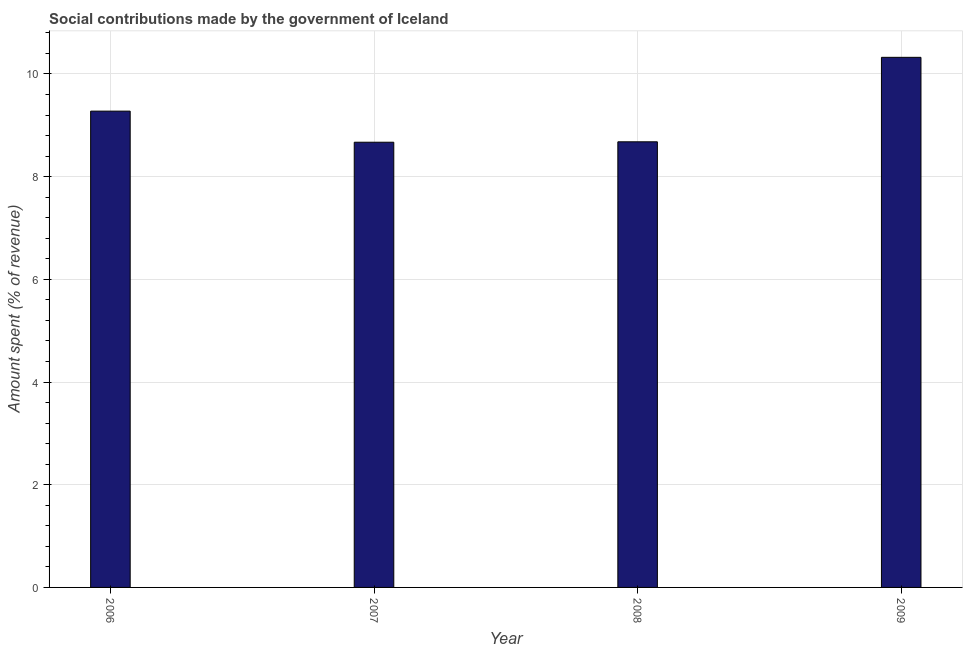Does the graph contain grids?
Offer a very short reply. Yes. What is the title of the graph?
Make the answer very short. Social contributions made by the government of Iceland. What is the label or title of the Y-axis?
Offer a terse response. Amount spent (% of revenue). What is the amount spent in making social contributions in 2009?
Provide a succinct answer. 10.32. Across all years, what is the maximum amount spent in making social contributions?
Provide a succinct answer. 10.32. Across all years, what is the minimum amount spent in making social contributions?
Give a very brief answer. 8.67. In which year was the amount spent in making social contributions maximum?
Provide a short and direct response. 2009. What is the sum of the amount spent in making social contributions?
Provide a short and direct response. 36.95. What is the difference between the amount spent in making social contributions in 2008 and 2009?
Give a very brief answer. -1.65. What is the average amount spent in making social contributions per year?
Your response must be concise. 9.24. What is the median amount spent in making social contributions?
Ensure brevity in your answer.  8.98. In how many years, is the amount spent in making social contributions greater than 1.2 %?
Give a very brief answer. 4. Do a majority of the years between 2009 and 2007 (inclusive) have amount spent in making social contributions greater than 2.4 %?
Your answer should be very brief. Yes. Is the amount spent in making social contributions in 2008 less than that in 2009?
Provide a short and direct response. Yes. What is the difference between the highest and the second highest amount spent in making social contributions?
Your answer should be very brief. 1.05. What is the difference between the highest and the lowest amount spent in making social contributions?
Give a very brief answer. 1.65. In how many years, is the amount spent in making social contributions greater than the average amount spent in making social contributions taken over all years?
Make the answer very short. 2. How many bars are there?
Make the answer very short. 4. Are all the bars in the graph horizontal?
Your answer should be compact. No. What is the Amount spent (% of revenue) of 2006?
Give a very brief answer. 9.28. What is the Amount spent (% of revenue) of 2007?
Keep it short and to the point. 8.67. What is the Amount spent (% of revenue) of 2008?
Ensure brevity in your answer.  8.68. What is the Amount spent (% of revenue) in 2009?
Give a very brief answer. 10.32. What is the difference between the Amount spent (% of revenue) in 2006 and 2007?
Your answer should be very brief. 0.61. What is the difference between the Amount spent (% of revenue) in 2006 and 2008?
Offer a terse response. 0.6. What is the difference between the Amount spent (% of revenue) in 2006 and 2009?
Provide a succinct answer. -1.05. What is the difference between the Amount spent (% of revenue) in 2007 and 2008?
Your response must be concise. -0.01. What is the difference between the Amount spent (% of revenue) in 2007 and 2009?
Your response must be concise. -1.65. What is the difference between the Amount spent (% of revenue) in 2008 and 2009?
Make the answer very short. -1.65. What is the ratio of the Amount spent (% of revenue) in 2006 to that in 2007?
Your answer should be very brief. 1.07. What is the ratio of the Amount spent (% of revenue) in 2006 to that in 2008?
Provide a succinct answer. 1.07. What is the ratio of the Amount spent (% of revenue) in 2006 to that in 2009?
Keep it short and to the point. 0.9. What is the ratio of the Amount spent (% of revenue) in 2007 to that in 2009?
Provide a short and direct response. 0.84. What is the ratio of the Amount spent (% of revenue) in 2008 to that in 2009?
Make the answer very short. 0.84. 